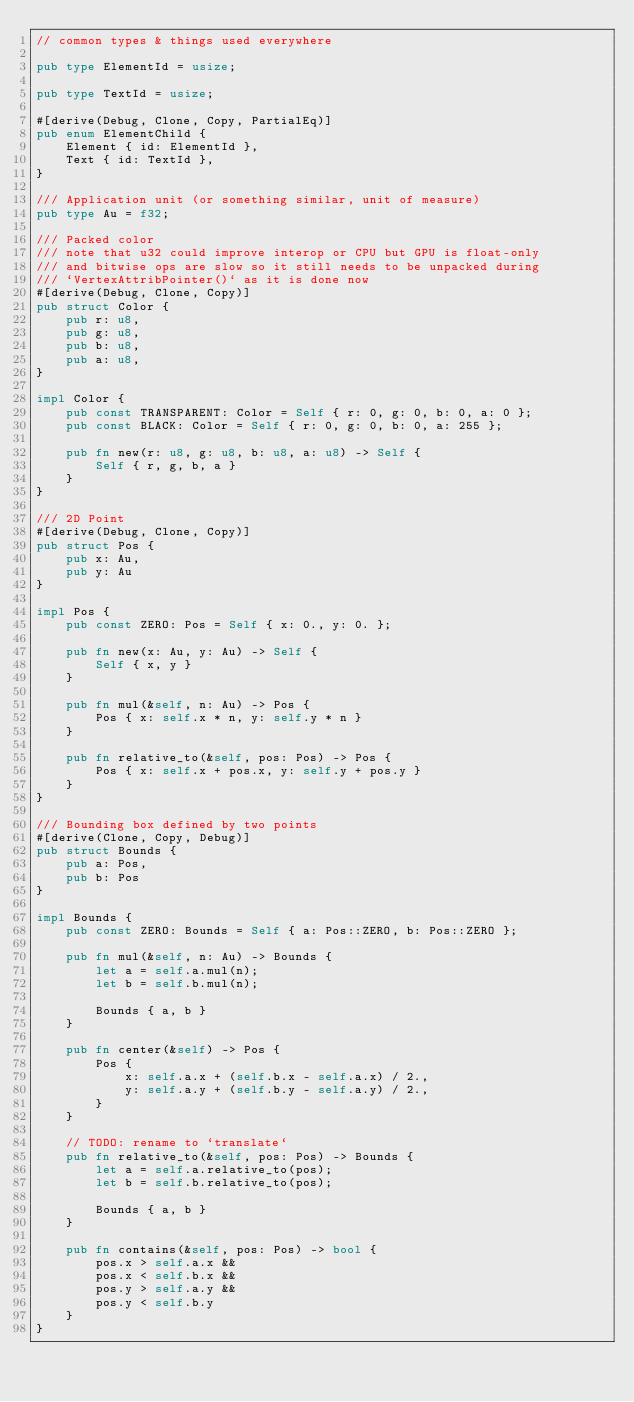Convert code to text. <code><loc_0><loc_0><loc_500><loc_500><_Rust_>// common types & things used everywhere

pub type ElementId = usize;

pub type TextId = usize;

#[derive(Debug, Clone, Copy, PartialEq)]
pub enum ElementChild {
    Element { id: ElementId },
    Text { id: TextId },
}

/// Application unit (or something similar, unit of measure)
pub type Au = f32;

/// Packed color
/// note that u32 could improve interop or CPU but GPU is float-only
/// and bitwise ops are slow so it still needs to be unpacked during
/// `VertexAttribPointer()` as it is done now
#[derive(Debug, Clone, Copy)]
pub struct Color {
    pub r: u8,
    pub g: u8,
    pub b: u8,
    pub a: u8,
}

impl Color {
    pub const TRANSPARENT: Color = Self { r: 0, g: 0, b: 0, a: 0 };
    pub const BLACK: Color = Self { r: 0, g: 0, b: 0, a: 255 };

    pub fn new(r: u8, g: u8, b: u8, a: u8) -> Self {
        Self { r, g, b, a }
    }
}

/// 2D Point
#[derive(Debug, Clone, Copy)]
pub struct Pos {
    pub x: Au,
    pub y: Au
}

impl Pos {
    pub const ZERO: Pos = Self { x: 0., y: 0. };

    pub fn new(x: Au, y: Au) -> Self {
        Self { x, y }
    }

    pub fn mul(&self, n: Au) -> Pos {
        Pos { x: self.x * n, y: self.y * n }
    }

    pub fn relative_to(&self, pos: Pos) -> Pos {
        Pos { x: self.x + pos.x, y: self.y + pos.y }
    }
}

/// Bounding box defined by two points
#[derive(Clone, Copy, Debug)]
pub struct Bounds {
    pub a: Pos,
    pub b: Pos
}

impl Bounds {
    pub const ZERO: Bounds = Self { a: Pos::ZERO, b: Pos::ZERO };

    pub fn mul(&self, n: Au) -> Bounds {
        let a = self.a.mul(n);
        let b = self.b.mul(n);

        Bounds { a, b }
    }

    pub fn center(&self) -> Pos {
        Pos {
            x: self.a.x + (self.b.x - self.a.x) / 2.,
            y: self.a.y + (self.b.y - self.a.y) / 2.,
        }
    }

    // TODO: rename to `translate`
    pub fn relative_to(&self, pos: Pos) -> Bounds {
        let a = self.a.relative_to(pos);
        let b = self.b.relative_to(pos);

        Bounds { a, b }
    }

    pub fn contains(&self, pos: Pos) -> bool {
        pos.x > self.a.x &&
        pos.x < self.b.x &&
        pos.y > self.a.y &&
        pos.y < self.b.y
    }
}
</code> 